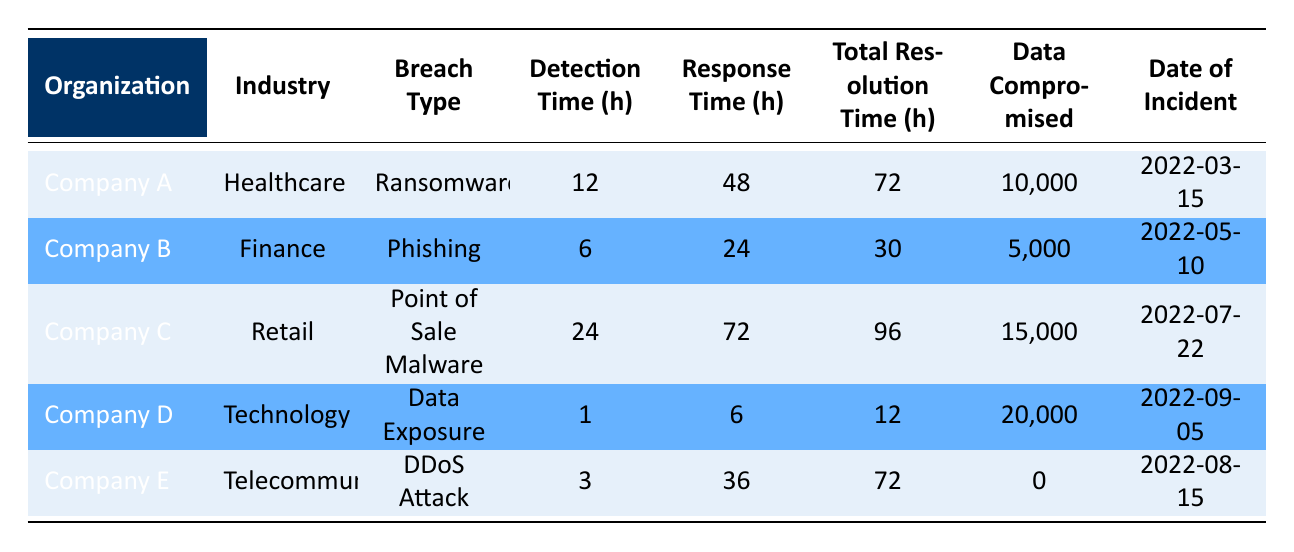What organization experienced the quickest incident detection time? The table shows that Company D had the fastest incident detection time of 1 hour compared to other organizations.
Answer: Company D What was the total time to resolution for Company C? According to the table, the total time to resolution for Company C is 96 hours, as indicated in the corresponding row.
Answer: 96 hours Which breach type had the highest amount of data compromised? By examining the data, Company D has the highest data compromised amount of 20,000, more than any other incident in the table.
Answer: Data Exposure What is the average response time across all organizations? To find the average response time, sum the response times (48 + 24 + 72 + 6 + 36 = 186) and divide by the number of organizations (5). Thus, the average response time is 186/5 = 37.2 hours.
Answer: 37.2 hours Did any organization have no data compromised during the incident? Yes, according to the table, Company E had zero data compromised as indicated in its respective row.
Answer: Yes Which organization had the longest total time to resolution? By reviewing the total time to resolution values in the table, Company C's 96 hours is the longest among all listed organizations.
Answer: Company C Is there a correlation between incident detection time and total resolution time based on the data? Yes, examining the data reveals that there typically seems to be a trend where longer detection times correspond with longer total resolution times. For example, Company C had the longest detection time of 24 hours and the longest total resolution time of 96 hours.
Answer: Yes What percentage of data was compromised in the incident involving Company B? The table indicates that Company B compromised 5,000 records. Assuming the total data available is not listed, the specific percentage cannot be calculated without additional data context. However, as a standalone figure, the answer is based on the number provided in the table.
Answer: Not calculable Which industry had the lowest response time in these incidents? By analyzing the data, it’s clear that Company D in the Technology industry had the lowest response time of only 6 hours compared to others.
Answer: Technology 